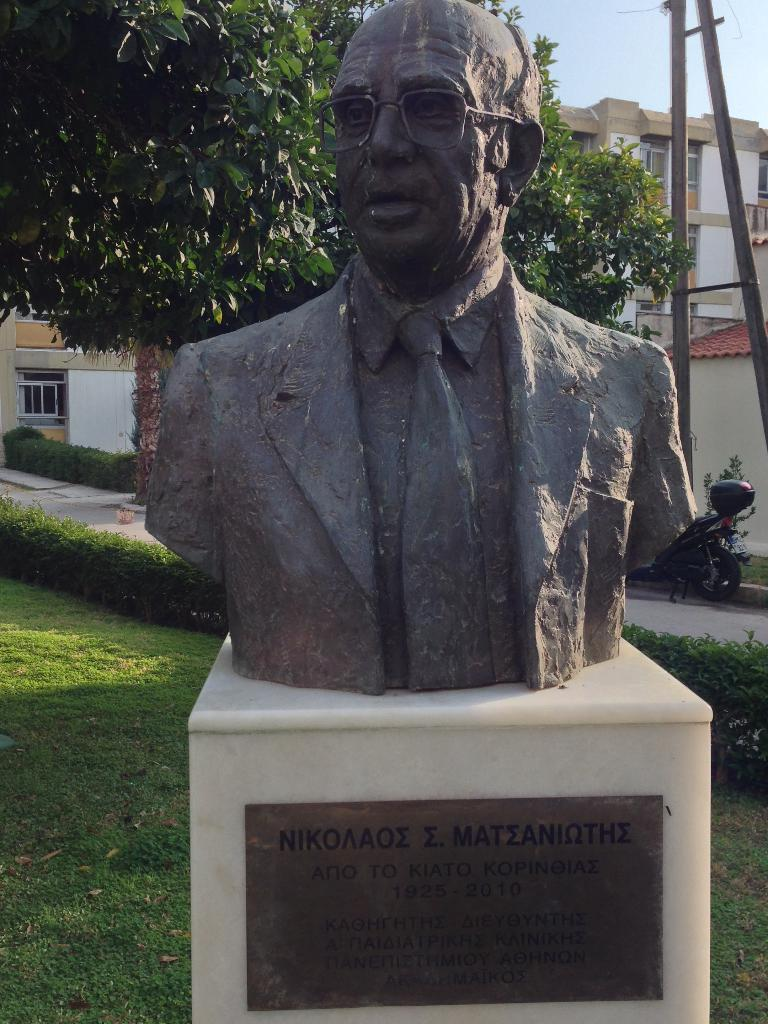What is the main subject of the statue in the image? There is a statue of a man in the image. What type of vehicle is present in the image? There is a motorbike with a luggage box in the image. What type of vegetation can be seen in the image? There are trees in the image. What type of ground surface is visible in the image? There is a path and grass in the image. What type of structures can be seen in the image? There are buildings with windows in the image. What is visible in the background of the image? The sky is visible in the background of the image. Can you tell me how many flocks of birds are flying over the buildings in the image? There is no mention of birds or flocks in the image, so it is not possible to answer this question. What religious symbol can be seen on the statue in the image? There is no religious symbol mentioned on the statue in the image. What key is used to unlock the luggage box on the motorbike in the image? There is no key visible in the image, and it is not mentioned if the luggage box is locked or unlocked. 